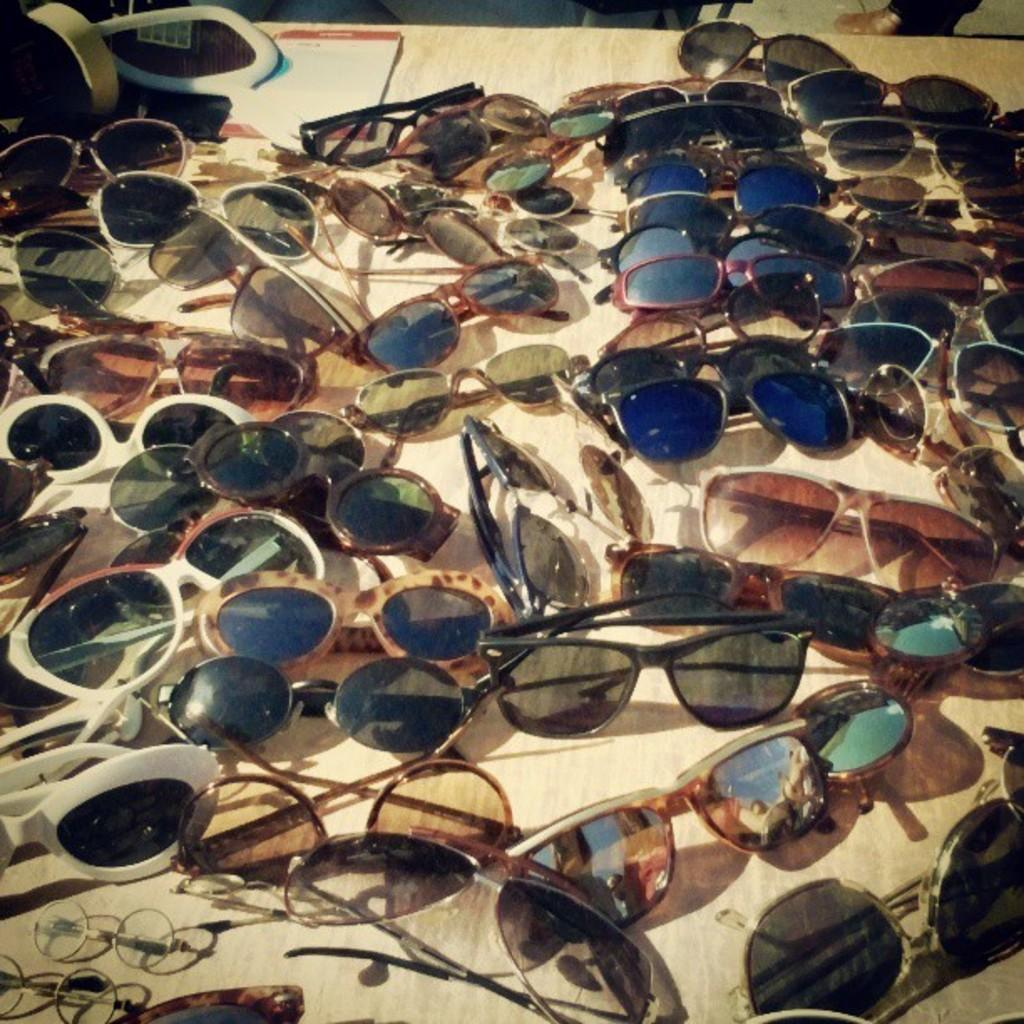What type of protective eyewear is present in the image? There are goggles in the image. What can be seen on the table in the image? There are objects on the table in the image. Can you describe anything visible in the background of the image? A person's leg is visible in the background of the image. What type of steam is coming from the goggles in the image? There is no steam present in the image; it only features goggles, objects on the table, and a person's leg in the background. 